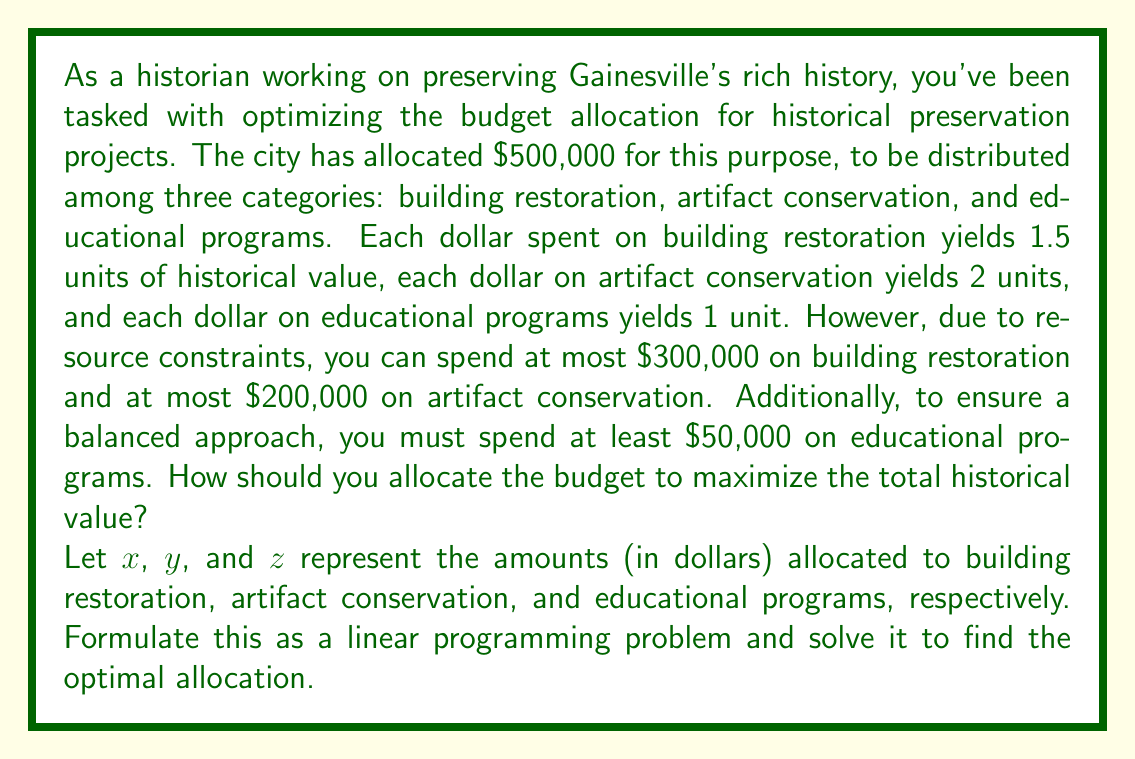Can you answer this question? To solve this linear programming problem, we'll follow these steps:

1) Formulate the objective function and constraints:

   Objective function (maximize historical value):
   $$\text{Maximize } 1.5x + 2y + z$$

   Constraints:
   $$x + y + z \leq 500000 \text{ (total budget)}$$
   $$x \leq 300000 \text{ (building restoration limit)}$$
   $$y \leq 200000 \text{ (artifact conservation limit)}$$
   $$z \geq 50000 \text{ (minimum for educational programs)}$$
   $$x, y, z \geq 0 \text{ (non-negativity)}$$

2) We can solve this using the simplex method or graphical method. Given the constraints, we can deduce:

   - We should maximize spending on artifact conservation ($y$) as it yields the highest value per dollar.
   - After that, we should maximize building restoration ($x$) as it's the next most efficient.
   - We should allocate the minimum required to educational programs ($z$).

3) Following this logic:

   $y = 200000$ (maximum allowed for artifact conservation)
   $z = 50000$ (minimum required for educational programs)
   $x = 500000 - 200000 - 50000 = 250000$ (remaining budget for building restoration)

4) Check if this solution satisfies all constraints:
   - Total budget: $250000 + 200000 + 50000 = 500000$ ✓
   - Building restoration limit: $250000 \leq 300000$ ✓
   - Artifact conservation limit: $200000 \leq 200000$ ✓
   - Educational programs minimum: $50000 \geq 50000$ ✓
   - All values are non-negative ✓

5) Calculate the total historical value:
   $$1.5(250000) + 2(200000) + 1(50000) = 825000$$

This allocation maximizes the historical value while satisfying all constraints.
Answer: The optimal budget allocation is:
Building restoration: $250,000
Artifact conservation: $200,000
Educational programs: $50,000
This allocation yields a maximum historical value of 825,000 units. 